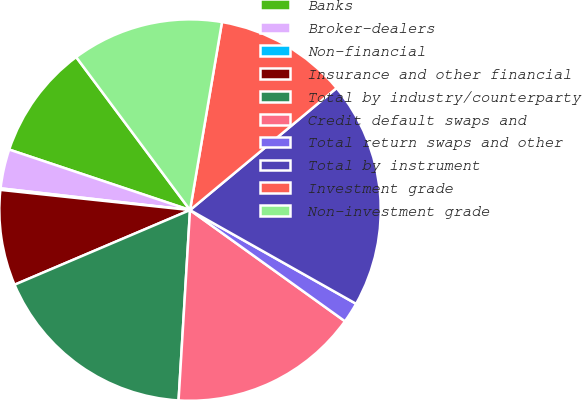Convert chart to OTSL. <chart><loc_0><loc_0><loc_500><loc_500><pie_chart><fcel>Banks<fcel>Broker-dealers<fcel>Non-financial<fcel>Insurance and other financial<fcel>Total by industry/counterparty<fcel>Credit default swaps and<fcel>Total return swaps and other<fcel>Total by instrument<fcel>Investment grade<fcel>Non-investment grade<nl><fcel>9.68%<fcel>3.32%<fcel>0.13%<fcel>8.09%<fcel>17.64%<fcel>16.05%<fcel>1.73%<fcel>19.23%<fcel>11.27%<fcel>12.86%<nl></chart> 